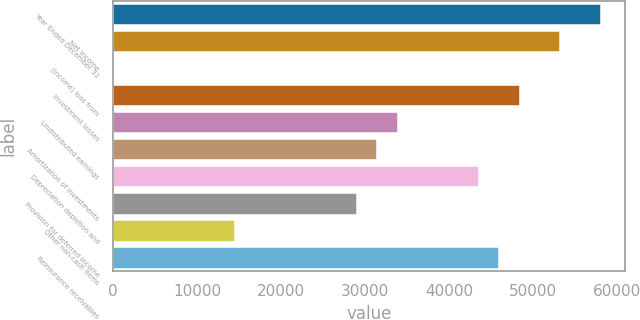Convert chart to OTSL. <chart><loc_0><loc_0><loc_500><loc_500><bar_chart><fcel>Year Ended December 31<fcel>Net income<fcel>(Income) loss from<fcel>Investment losses<fcel>Undistributed earnings<fcel>Amortization of investments<fcel>Depreciation depletion and<fcel>Provision for deferred income<fcel>Other non-cash items<fcel>Reinsurance receivables<nl><fcel>58050.8<fcel>53213.4<fcel>2<fcel>48376<fcel>33863.8<fcel>31445.1<fcel>43538.6<fcel>29026.4<fcel>14514.2<fcel>45957.3<nl></chart> 